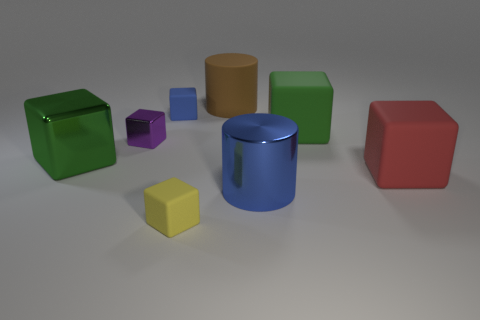Add 2 red cylinders. How many objects exist? 10 Subtract all green cylinders. Subtract all purple cubes. How many cylinders are left? 2 Subtract all green balls. How many yellow cylinders are left? 0 Subtract all blue shiny cylinders. Subtract all big things. How many objects are left? 2 Add 6 red rubber objects. How many red rubber objects are left? 7 Add 5 yellow matte things. How many yellow matte things exist? 6 Subtract all brown cylinders. How many cylinders are left? 1 Subtract all small blue matte cubes. How many cubes are left? 5 Subtract 0 green cylinders. How many objects are left? 8 Subtract all cubes. How many objects are left? 2 